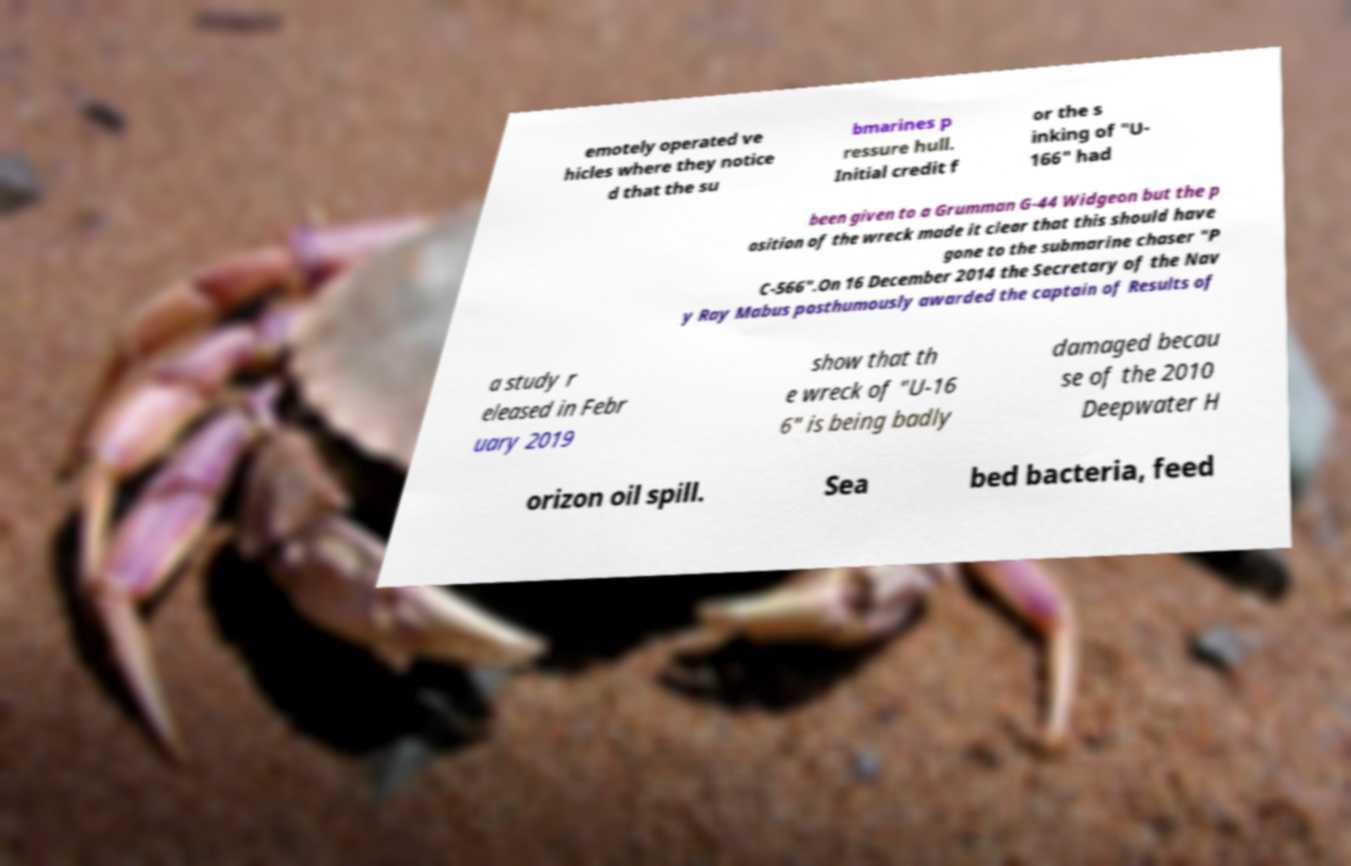Could you extract and type out the text from this image? emotely operated ve hicles where they notice d that the su bmarines p ressure hull. Initial credit f or the s inking of "U- 166" had been given to a Grumman G-44 Widgeon but the p osition of the wreck made it clear that this should have gone to the submarine chaser "P C-566".On 16 December 2014 the Secretary of the Nav y Ray Mabus posthumously awarded the captain of Results of a study r eleased in Febr uary 2019 show that th e wreck of "U-16 6" is being badly damaged becau se of the 2010 Deepwater H orizon oil spill. Sea bed bacteria, feed 